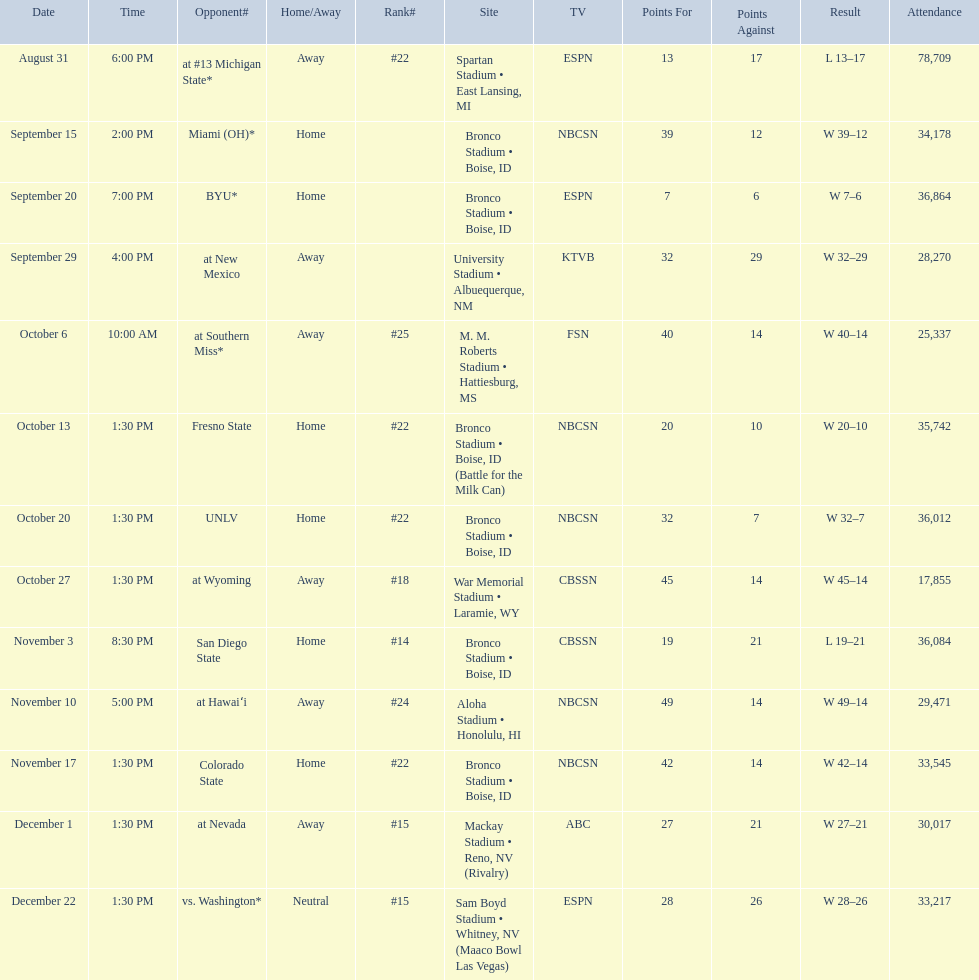Did the broncos on september 29th win by less than 5 points? Yes. 